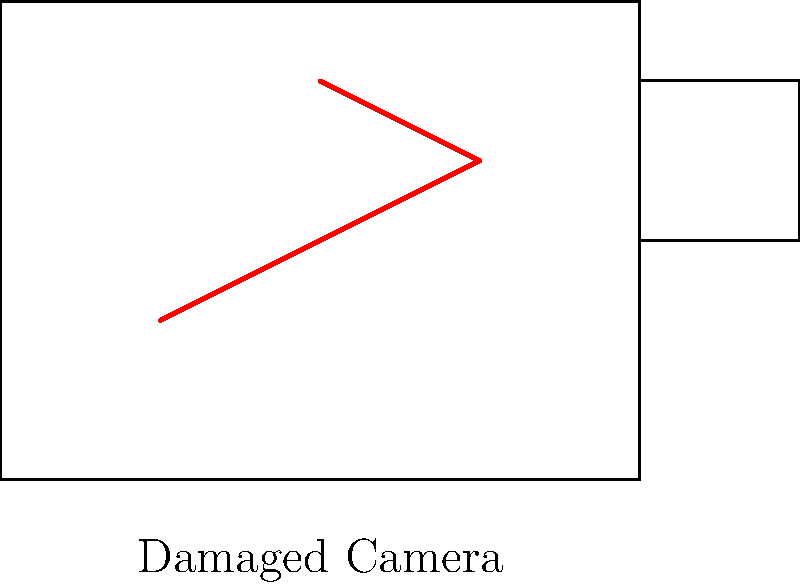In an image classification model for insurance claims, what feature extraction technique would be most effective for identifying the crack in the damaged camera shown above? To identify the crack in the damaged camera, we need to consider the following steps:

1. Image preprocessing: Enhance the contrast and edges in the image to make the crack more visible.

2. Feature extraction: This is the key step for identifying the crack. We need to choose a technique that can detect linear structures and abrupt changes in pixel intensity.

3. The most effective feature extraction technique for this scenario would be edge detection, specifically using the Canny edge detection algorithm. Here's why:

   a. Canny edge detection is particularly good at identifying sharp changes in intensity, which is characteristic of cracks.
   
   b. It can detect edges at various scales, which is useful for identifying cracks of different sizes.
   
   c. It's less sensitive to noise compared to other edge detection methods, making it more reliable for real-world images.

4. After edge detection, we would likely use additional techniques such as the Hough transform to identify straight lines that could represent cracks.

5. These extracted features would then be fed into a machine learning model (e.g., a convolutional neural network) to classify whether the equipment is damaged based on the presence and characteristics of the detected edges.

Given your experience with equipment loss, this approach would be particularly relevant for quickly and accurately identifying damaged equipment in insurance claim images.
Answer: Canny edge detection 